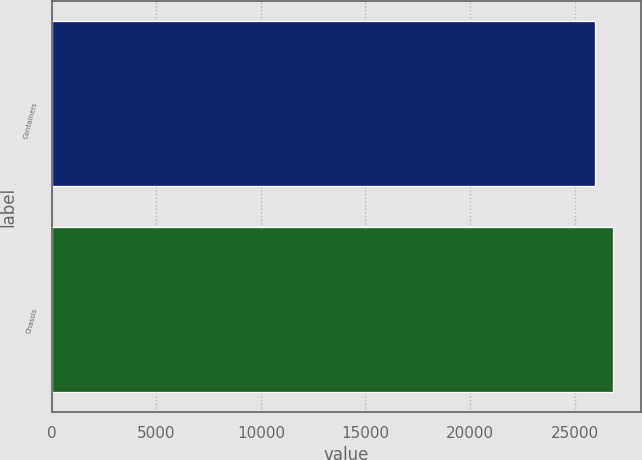Convert chart. <chart><loc_0><loc_0><loc_500><loc_500><bar_chart><fcel>Containers<fcel>Chassis<nl><fcel>25998<fcel>26837<nl></chart> 